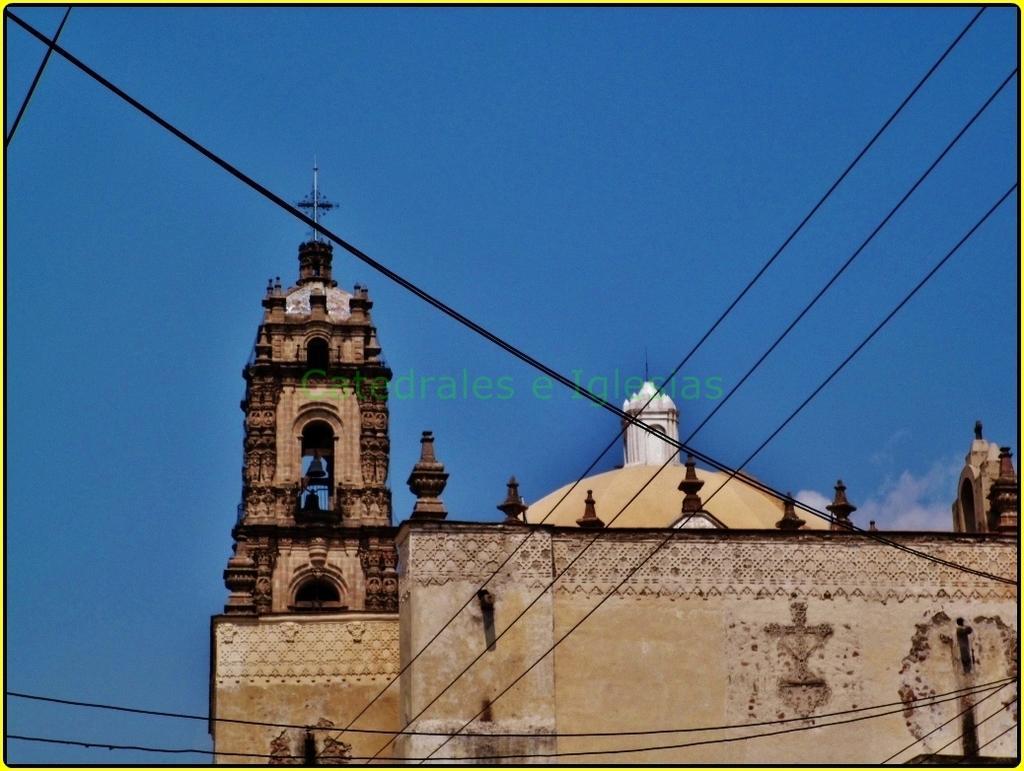In one or two sentences, can you explain what this image depicts? In this image at the bottom there is a building, and in the foreground there are some wires. At the top of the image there is sky. 